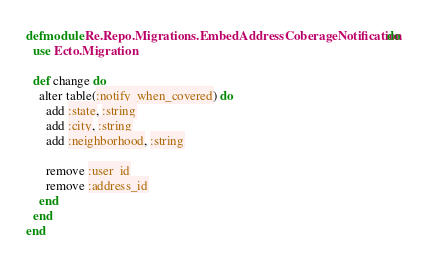<code> <loc_0><loc_0><loc_500><loc_500><_Elixir_>defmodule Re.Repo.Migrations.EmbedAddressCoberageNotification do
  use Ecto.Migration

  def change do
    alter table(:notify_when_covered) do
      add :state, :string
      add :city, :string
      add :neighborhood, :string

      remove :user_id
      remove :address_id
    end
  end
end
</code> 